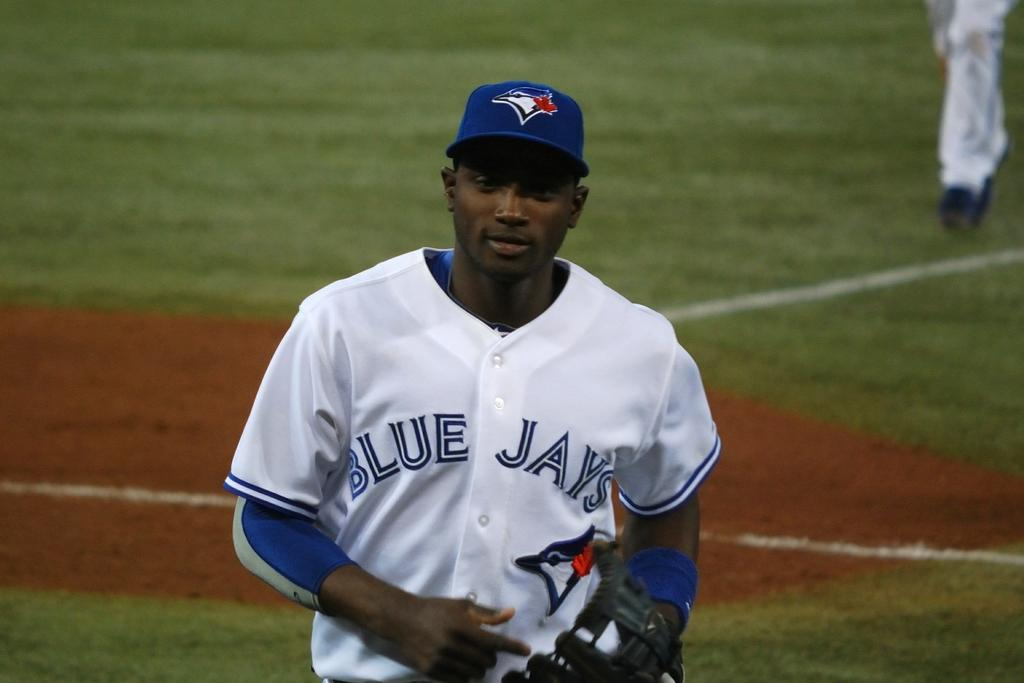Provide a one-sentence caption for the provided image. A Blue Jays baseball player on the field. 